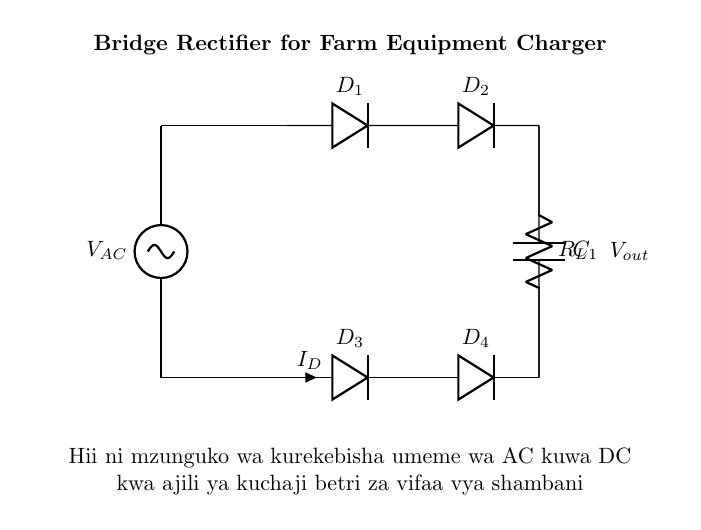What is the type of current that this circuit converts? The circuit converts alternating current (AC) to direct current (DC), which is indicated by the functionality of the bridge rectifier.
Answer: AC to DC What do the diodes in the diagram do? The diodes act as electronic switches that allow current to pass in one direction while blocking it in the opposite direction, facilitating rectification.
Answer: Rectification How many diodes are used in this circuit? There are four diodes used in the bridge rectifier configuration, which are labeled as D1, D2, D3, and D4 in the diagram.
Answer: Four What component smoothens the output voltage? The capacitor (C1) is responsible for smoothing the output voltage by storing energy and releasing it slowly, reducing fluctuations in the output.
Answer: Capacitor How is the load connected in this circuit? The load resistor (R_L) is connected in parallel with the capacitor, allowing the stored energy to power the connected equipment once the voltage has been rectified and smoothed.
Answer: Parallel What is the primary function of this circuit? The primary function of this circuit is to charge batteries for farm equipment maintenance by converting and regulating the electrical input.
Answer: Battery charging 